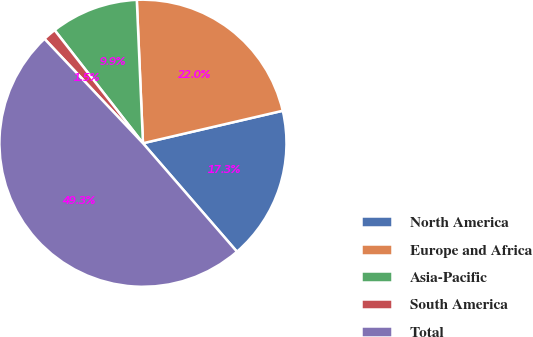Convert chart to OTSL. <chart><loc_0><loc_0><loc_500><loc_500><pie_chart><fcel>North America<fcel>Europe and Africa<fcel>Asia-Pacific<fcel>South America<fcel>Total<nl><fcel>17.27%<fcel>22.05%<fcel>9.87%<fcel>1.48%<fcel>49.33%<nl></chart> 